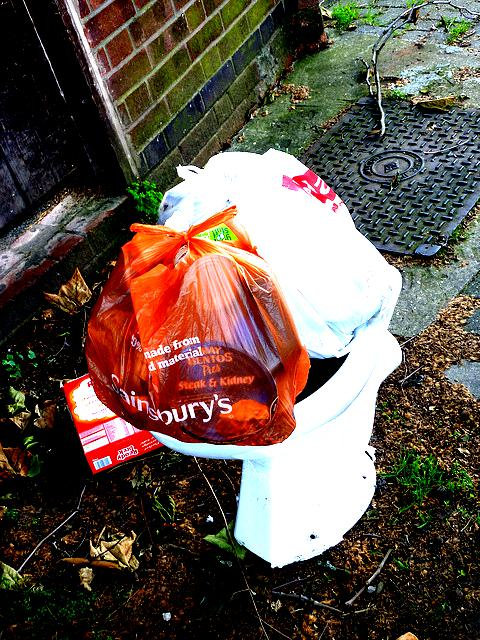Does this image suggest anything about the behavior or habits of people in the area? Yes, the image may suggest a lack of adherence to proper waste disposal protocols by the local residents or passersby. This could indicate either a deficiency in waste management services or a disregard for communal cleanliness standards. Such behavior might be symptomatic of larger issues, such as inadequate public infrastructure or lack of environmental education and awareness among the population. Is there anything that local authorities or residents could do to improve the situation? Local authorities could increase the frequency of waste collection, add more disposal sites, or provide larger bins to accommodate the rubbish volume. Educational campaigns on the importance of proper waste disposal and the consequences of littering could improve resident habits. Incentive programs for reporting or reducing litter and community clean-up events might also foster a sense of pride and responsibility towards the local environment. 